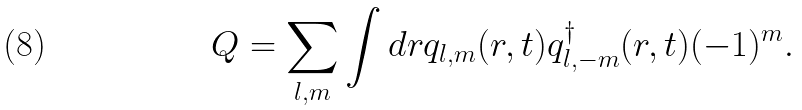<formula> <loc_0><loc_0><loc_500><loc_500>Q = \sum _ { l , m } \int d { r } q _ { l , m } ( { r } , t ) q ^ { \dagger } _ { l , - m } ( { r } , t ) ( - 1 ) ^ { m } .</formula> 